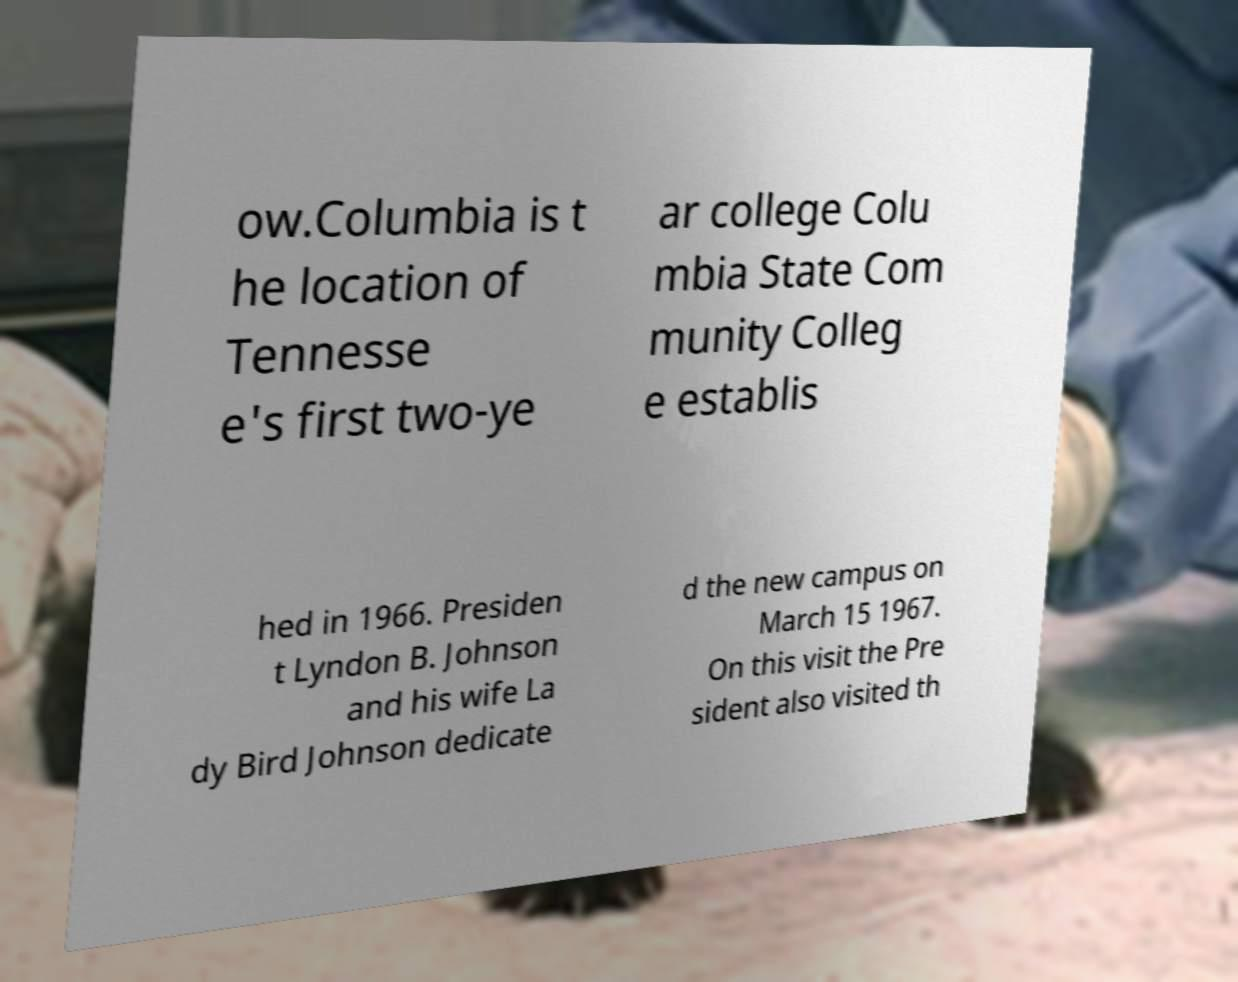Can you read and provide the text displayed in the image?This photo seems to have some interesting text. Can you extract and type it out for me? ow.Columbia is t he location of Tennesse e's first two-ye ar college Colu mbia State Com munity Colleg e establis hed in 1966. Presiden t Lyndon B. Johnson and his wife La dy Bird Johnson dedicate d the new campus on March 15 1967. On this visit the Pre sident also visited th 